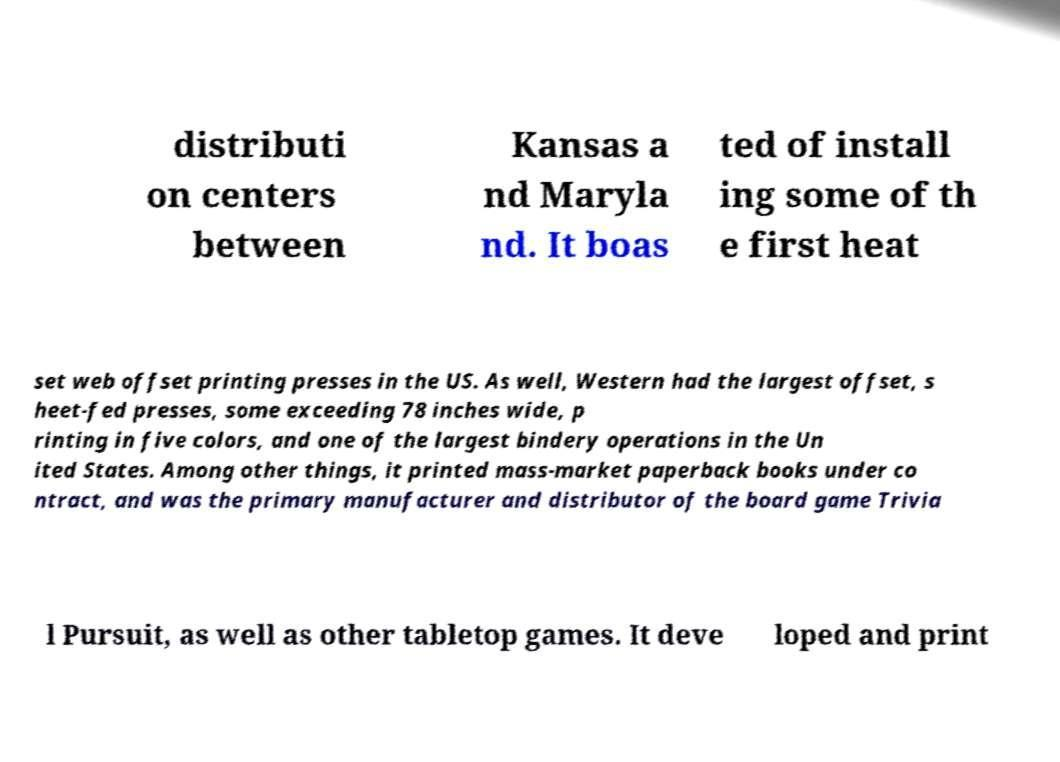Can you read and provide the text displayed in the image?This photo seems to have some interesting text. Can you extract and type it out for me? distributi on centers between Kansas a nd Maryla nd. It boas ted of install ing some of th e first heat set web offset printing presses in the US. As well, Western had the largest offset, s heet-fed presses, some exceeding 78 inches wide, p rinting in five colors, and one of the largest bindery operations in the Un ited States. Among other things, it printed mass-market paperback books under co ntract, and was the primary manufacturer and distributor of the board game Trivia l Pursuit, as well as other tabletop games. It deve loped and print 